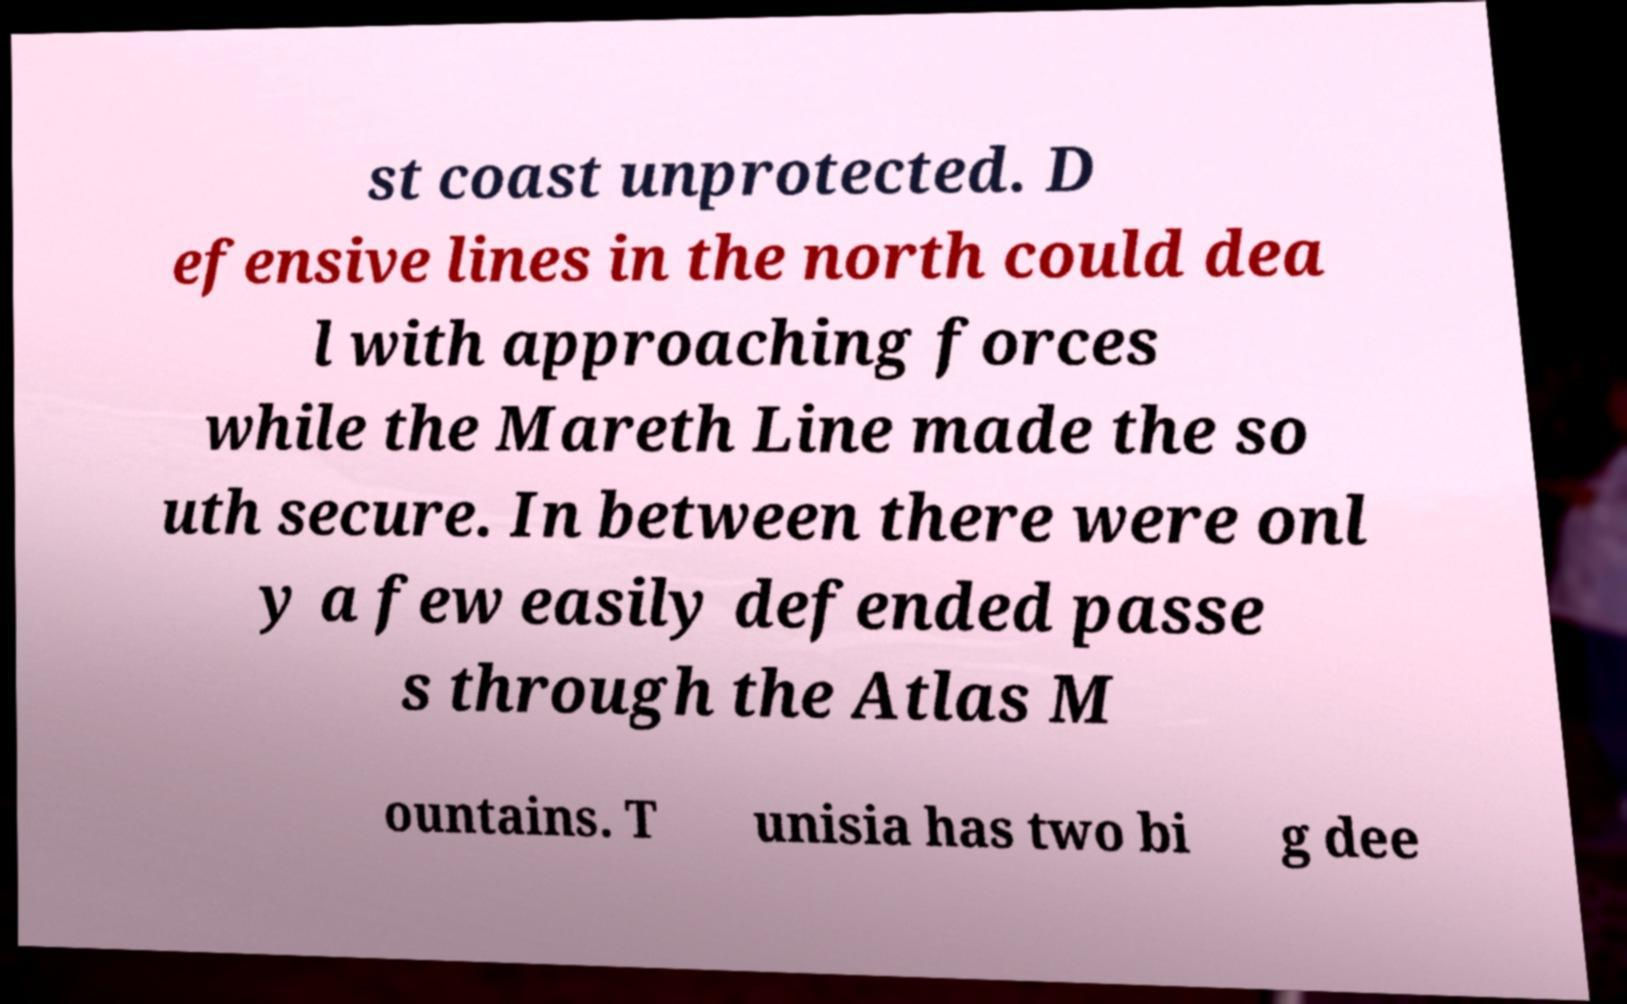What messages or text are displayed in this image? I need them in a readable, typed format. st coast unprotected. D efensive lines in the north could dea l with approaching forces while the Mareth Line made the so uth secure. In between there were onl y a few easily defended passe s through the Atlas M ountains. T unisia has two bi g dee 